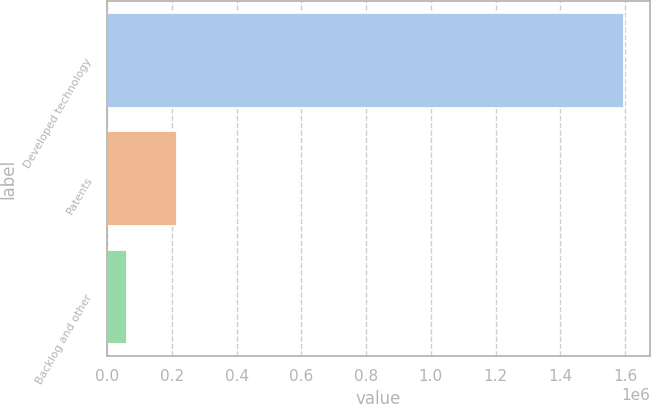<chart> <loc_0><loc_0><loc_500><loc_500><bar_chart><fcel>Developed technology<fcel>Patents<fcel>Backlog and other<nl><fcel>1.59757e+06<fcel>214352<fcel>60661<nl></chart> 